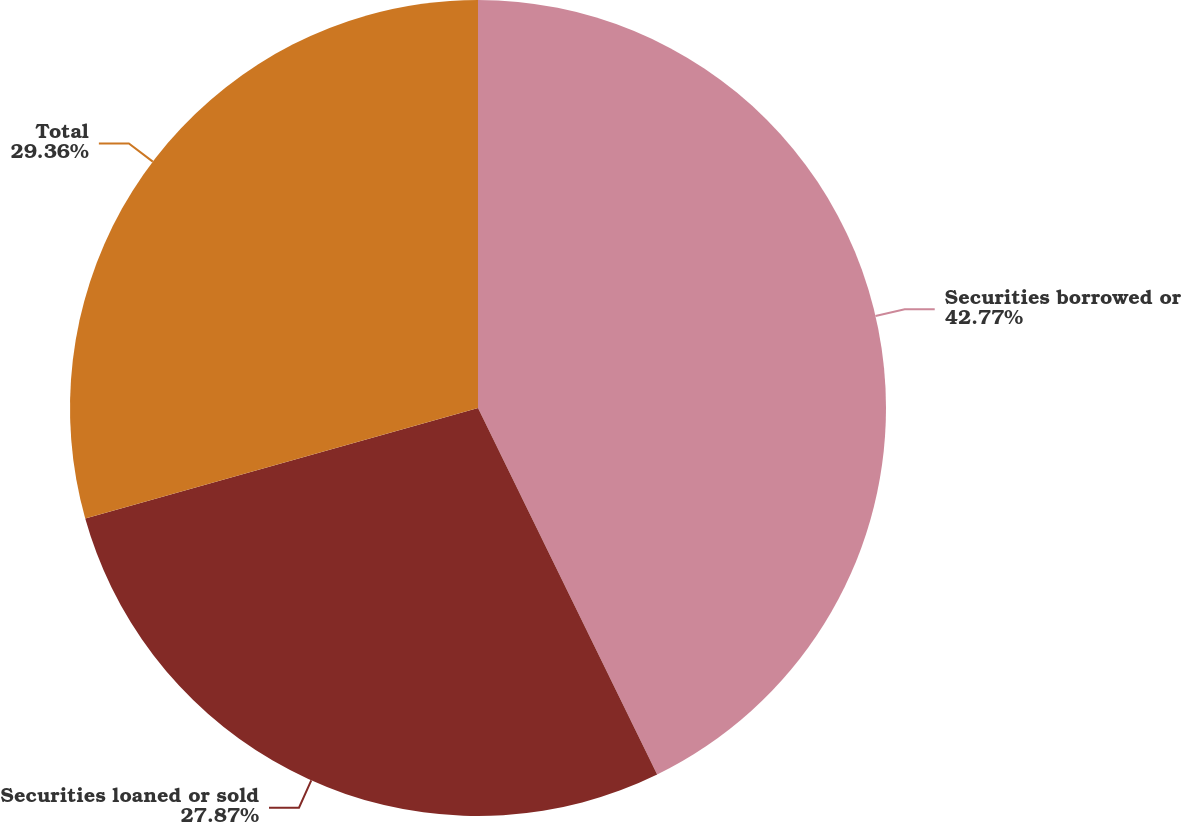<chart> <loc_0><loc_0><loc_500><loc_500><pie_chart><fcel>Securities borrowed or<fcel>Securities loaned or sold<fcel>Total<nl><fcel>42.76%<fcel>27.87%<fcel>29.36%<nl></chart> 